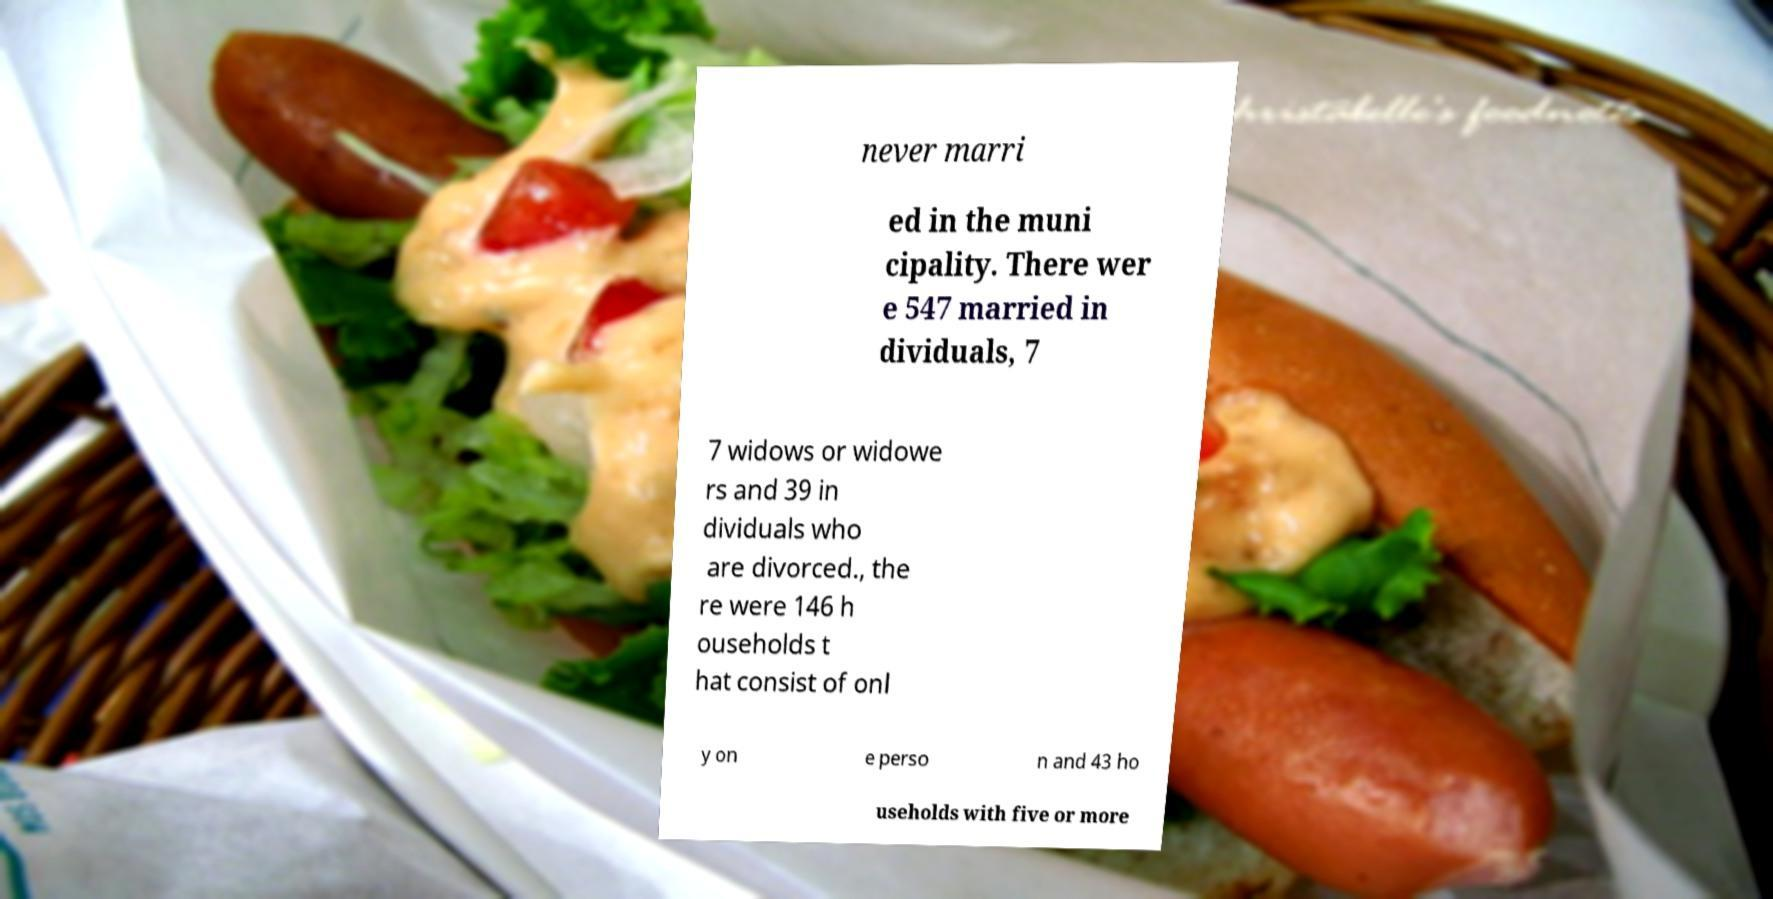Could you assist in decoding the text presented in this image and type it out clearly? never marri ed in the muni cipality. There wer e 547 married in dividuals, 7 7 widows or widowe rs and 39 in dividuals who are divorced., the re were 146 h ouseholds t hat consist of onl y on e perso n and 43 ho useholds with five or more 